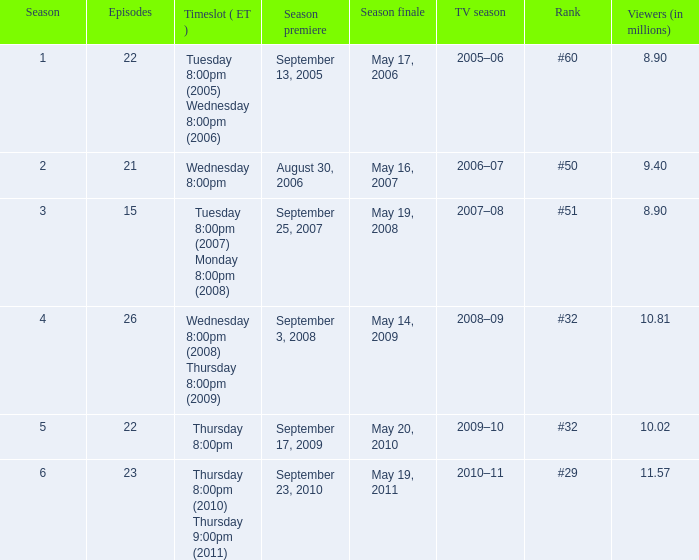In how many seasons was the position equivalent to #50? 1.0. 